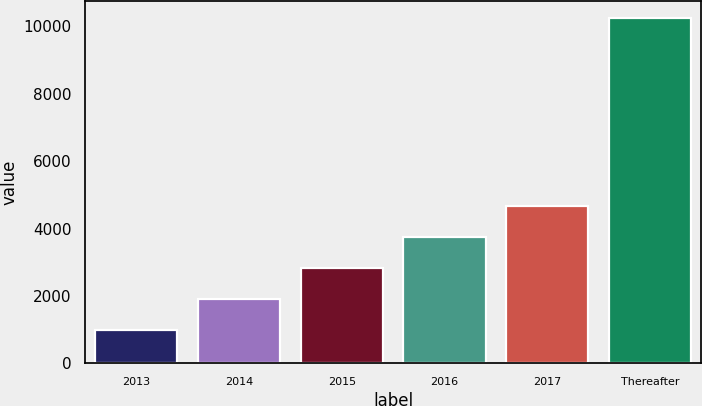Convert chart. <chart><loc_0><loc_0><loc_500><loc_500><bar_chart><fcel>2013<fcel>2014<fcel>2015<fcel>2016<fcel>2017<fcel>Thereafter<nl><fcel>976<fcel>1902.5<fcel>2829<fcel>3755.5<fcel>4682<fcel>10241<nl></chart> 